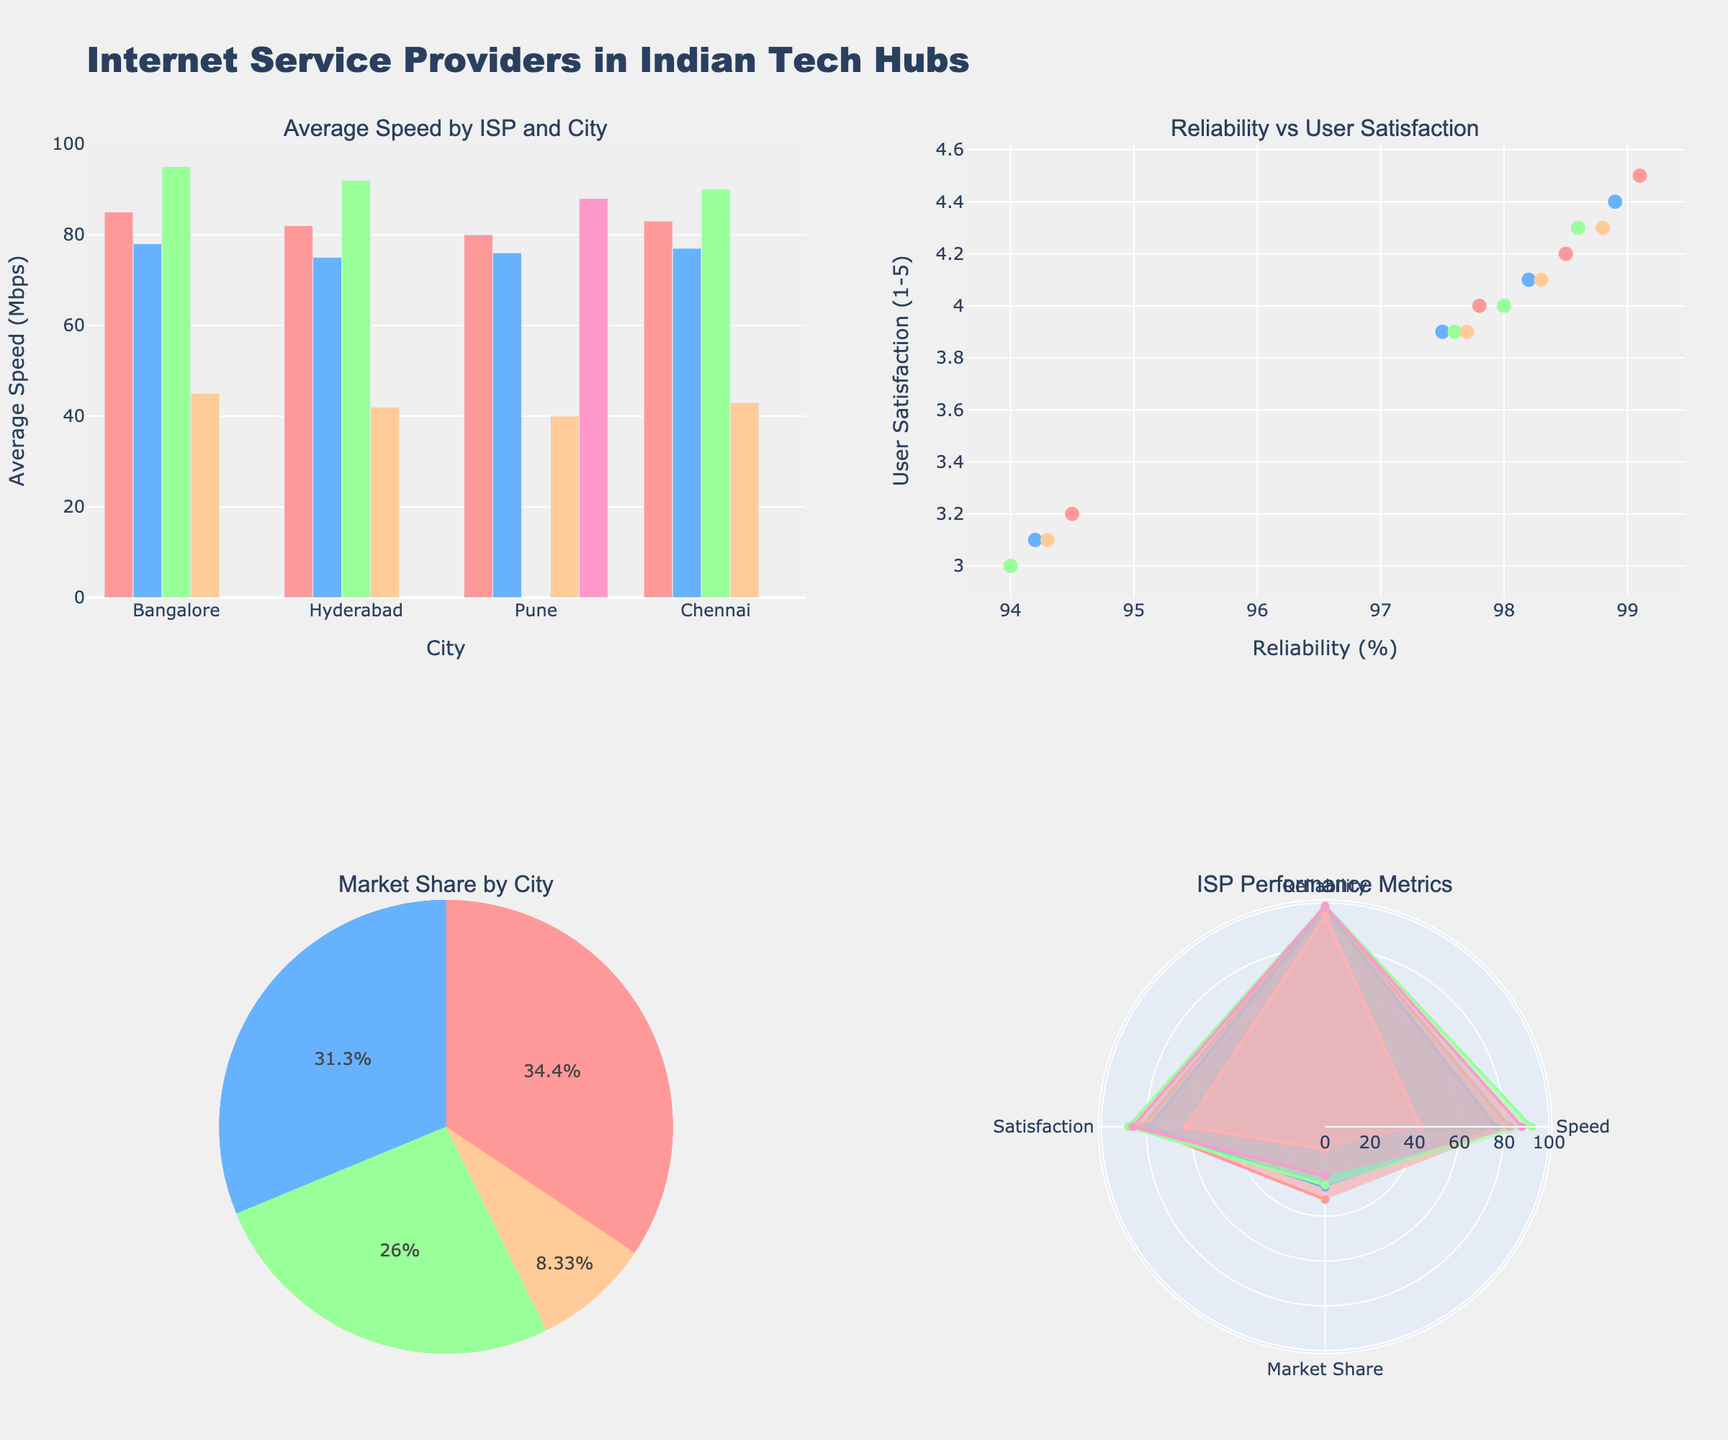What is the average speed of ACT Fibernet in Bangalore? Look at the bar chart titled "Average Speed by ISP and City" and find the bar representing ACT Fibernet in Bangalore. The bar is at 95 Mbps.
Answer: 95 Mbps What is the relationship between reliability and user satisfaction in Pune? Refer to the scatter plot titled "Reliability vs User Satisfaction". Identify the points corresponding to Pune. Then, observe whether the points show a clear trend between the two metrics. Most points are clustered together, suggesting a free relationship.
Answer: Separate relationship Which ISP has the highest market share in Hyderabad? Look at the pie chart titled "Market Share by City" for Hyderabad. The largest slice corresponds to Airtel, which has the highest market share.
Answer: Airtel What are the reliability and user satisfaction percentages for BSNL in all cities? Refer to the scatter plot titled "Reliability vs User Satisfaction". Identify the points for BSNL by filtering through the different markers. Calculate each city's BSNL reliability and satisfaction values: Bangalore (94.5, 3.2), Hyderabad (94.2, 3.1), Pune (94.0, 3.0), and Chennai (94.3, 3.1).
Answer: Bangalore: (94.5, 3.2), Hyderabad: (94.2, 3.1), Pune: (94.0, 3.0), Chennai: (94.3, 3.1) What is the average user satisfaction rate across all ISPs in the figure? Add all the average satisfaction rates from the data table and divide by the total count of ISPs. The values are 4.2, 4.0, 4.5, 3.2, 4.1, 4.4, 3.9, 3.1, 4.0, 3.9, 4.3, 3.0, 4.1, 4.3, 3.9, 3.1. Sum = 64. The average = 64/16 = 4.0
Answer: 4.0 Which city has the most balanced market share among ISPs? Look at the pie charts titled "Market Share by City". Compare the proportions of different slices (ISPs) in each city. Pune appears to have the most evenly distributed slices.
Answer: Pune Which ISP shows the best overall performance metrics? Refer to the polar plot titled "ISP Performance Metrics". Each ISP has a charted polygon showing their average metrics. ACT Fibernet has the most extended and fuller polygon, indicating the highest overall performance.
Answer: ACT Fibernet 